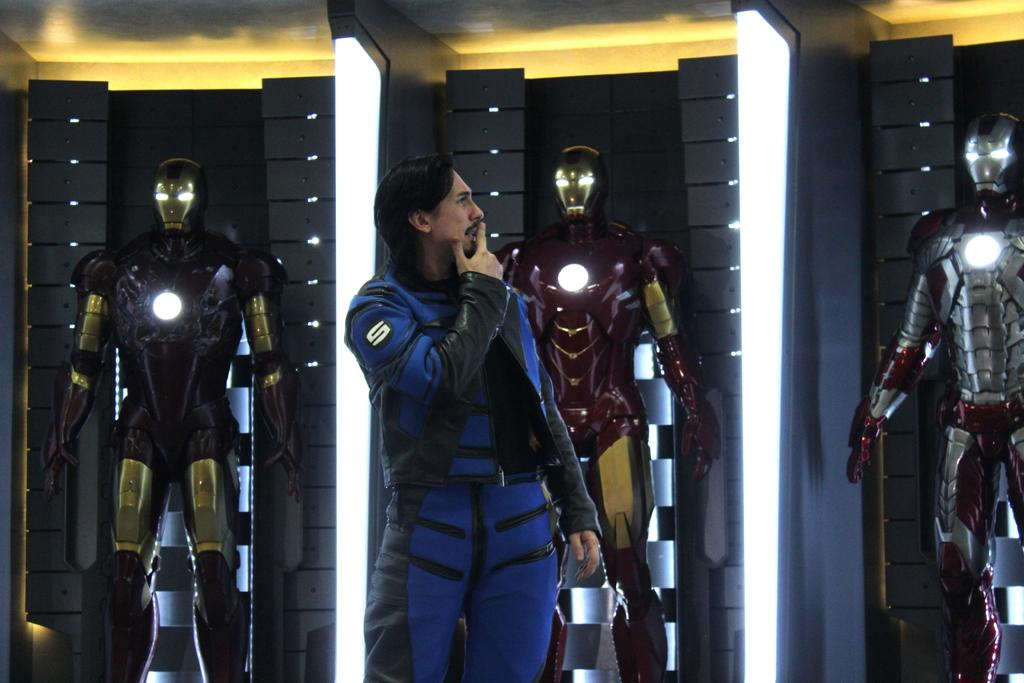What can be seen in the background of the image? In the background of the image, there are lights, robots, the ceiling, and metal panels. What is the primary subject of the image? There is a man standing in the image. What type of objects are the robots in the background? The robots in the background are made of metal, as indicated by the presence of metal panels. What type of drug can be seen in the image? There is no drug present in the image. How many pigs are visible in the image? There are no pigs present in the image. 